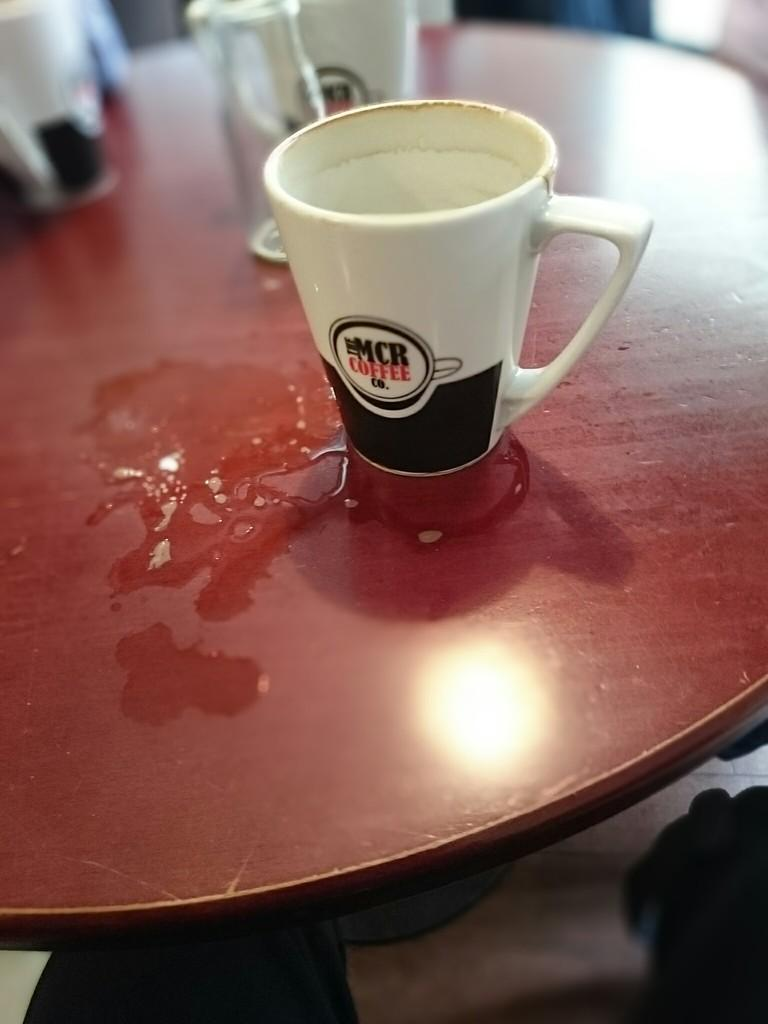What object is visible in the image? There is a cup in the image. Where is the cup located? The cup is placed on a table. How many houses can be seen in the image? There are no houses visible in the image; it only features a cup placed on a table. What type of blood is present in the image? There is no blood present in the image; it only features a cup placed on a table. 